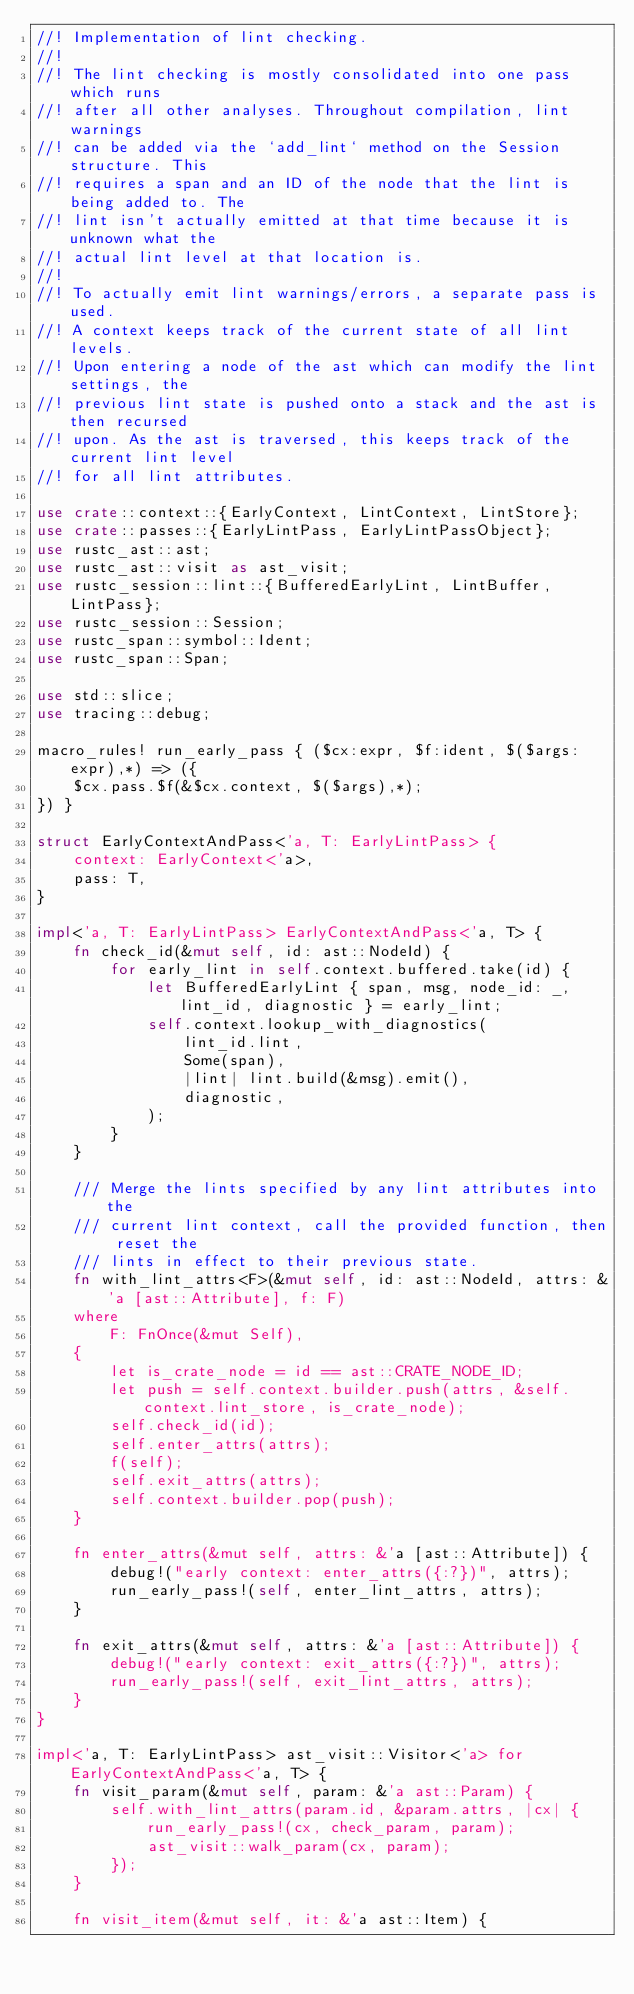Convert code to text. <code><loc_0><loc_0><loc_500><loc_500><_Rust_>//! Implementation of lint checking.
//!
//! The lint checking is mostly consolidated into one pass which runs
//! after all other analyses. Throughout compilation, lint warnings
//! can be added via the `add_lint` method on the Session structure. This
//! requires a span and an ID of the node that the lint is being added to. The
//! lint isn't actually emitted at that time because it is unknown what the
//! actual lint level at that location is.
//!
//! To actually emit lint warnings/errors, a separate pass is used.
//! A context keeps track of the current state of all lint levels.
//! Upon entering a node of the ast which can modify the lint settings, the
//! previous lint state is pushed onto a stack and the ast is then recursed
//! upon. As the ast is traversed, this keeps track of the current lint level
//! for all lint attributes.

use crate::context::{EarlyContext, LintContext, LintStore};
use crate::passes::{EarlyLintPass, EarlyLintPassObject};
use rustc_ast::ast;
use rustc_ast::visit as ast_visit;
use rustc_session::lint::{BufferedEarlyLint, LintBuffer, LintPass};
use rustc_session::Session;
use rustc_span::symbol::Ident;
use rustc_span::Span;

use std::slice;
use tracing::debug;

macro_rules! run_early_pass { ($cx:expr, $f:ident, $($args:expr),*) => ({
    $cx.pass.$f(&$cx.context, $($args),*);
}) }

struct EarlyContextAndPass<'a, T: EarlyLintPass> {
    context: EarlyContext<'a>,
    pass: T,
}

impl<'a, T: EarlyLintPass> EarlyContextAndPass<'a, T> {
    fn check_id(&mut self, id: ast::NodeId) {
        for early_lint in self.context.buffered.take(id) {
            let BufferedEarlyLint { span, msg, node_id: _, lint_id, diagnostic } = early_lint;
            self.context.lookup_with_diagnostics(
                lint_id.lint,
                Some(span),
                |lint| lint.build(&msg).emit(),
                diagnostic,
            );
        }
    }

    /// Merge the lints specified by any lint attributes into the
    /// current lint context, call the provided function, then reset the
    /// lints in effect to their previous state.
    fn with_lint_attrs<F>(&mut self, id: ast::NodeId, attrs: &'a [ast::Attribute], f: F)
    where
        F: FnOnce(&mut Self),
    {
        let is_crate_node = id == ast::CRATE_NODE_ID;
        let push = self.context.builder.push(attrs, &self.context.lint_store, is_crate_node);
        self.check_id(id);
        self.enter_attrs(attrs);
        f(self);
        self.exit_attrs(attrs);
        self.context.builder.pop(push);
    }

    fn enter_attrs(&mut self, attrs: &'a [ast::Attribute]) {
        debug!("early context: enter_attrs({:?})", attrs);
        run_early_pass!(self, enter_lint_attrs, attrs);
    }

    fn exit_attrs(&mut self, attrs: &'a [ast::Attribute]) {
        debug!("early context: exit_attrs({:?})", attrs);
        run_early_pass!(self, exit_lint_attrs, attrs);
    }
}

impl<'a, T: EarlyLintPass> ast_visit::Visitor<'a> for EarlyContextAndPass<'a, T> {
    fn visit_param(&mut self, param: &'a ast::Param) {
        self.with_lint_attrs(param.id, &param.attrs, |cx| {
            run_early_pass!(cx, check_param, param);
            ast_visit::walk_param(cx, param);
        });
    }

    fn visit_item(&mut self, it: &'a ast::Item) {</code> 